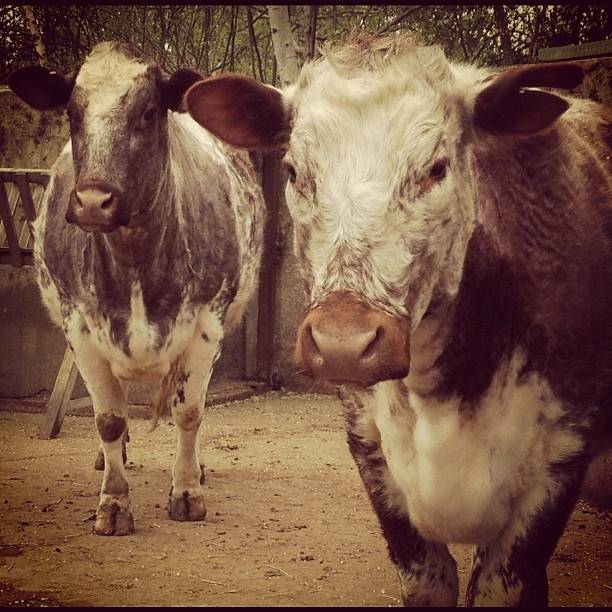Describe the objects in this image and their specific colors. I can see cow in black, maroon, gray, and tan tones and cow in black, maroon, tan, gray, and brown tones in this image. 